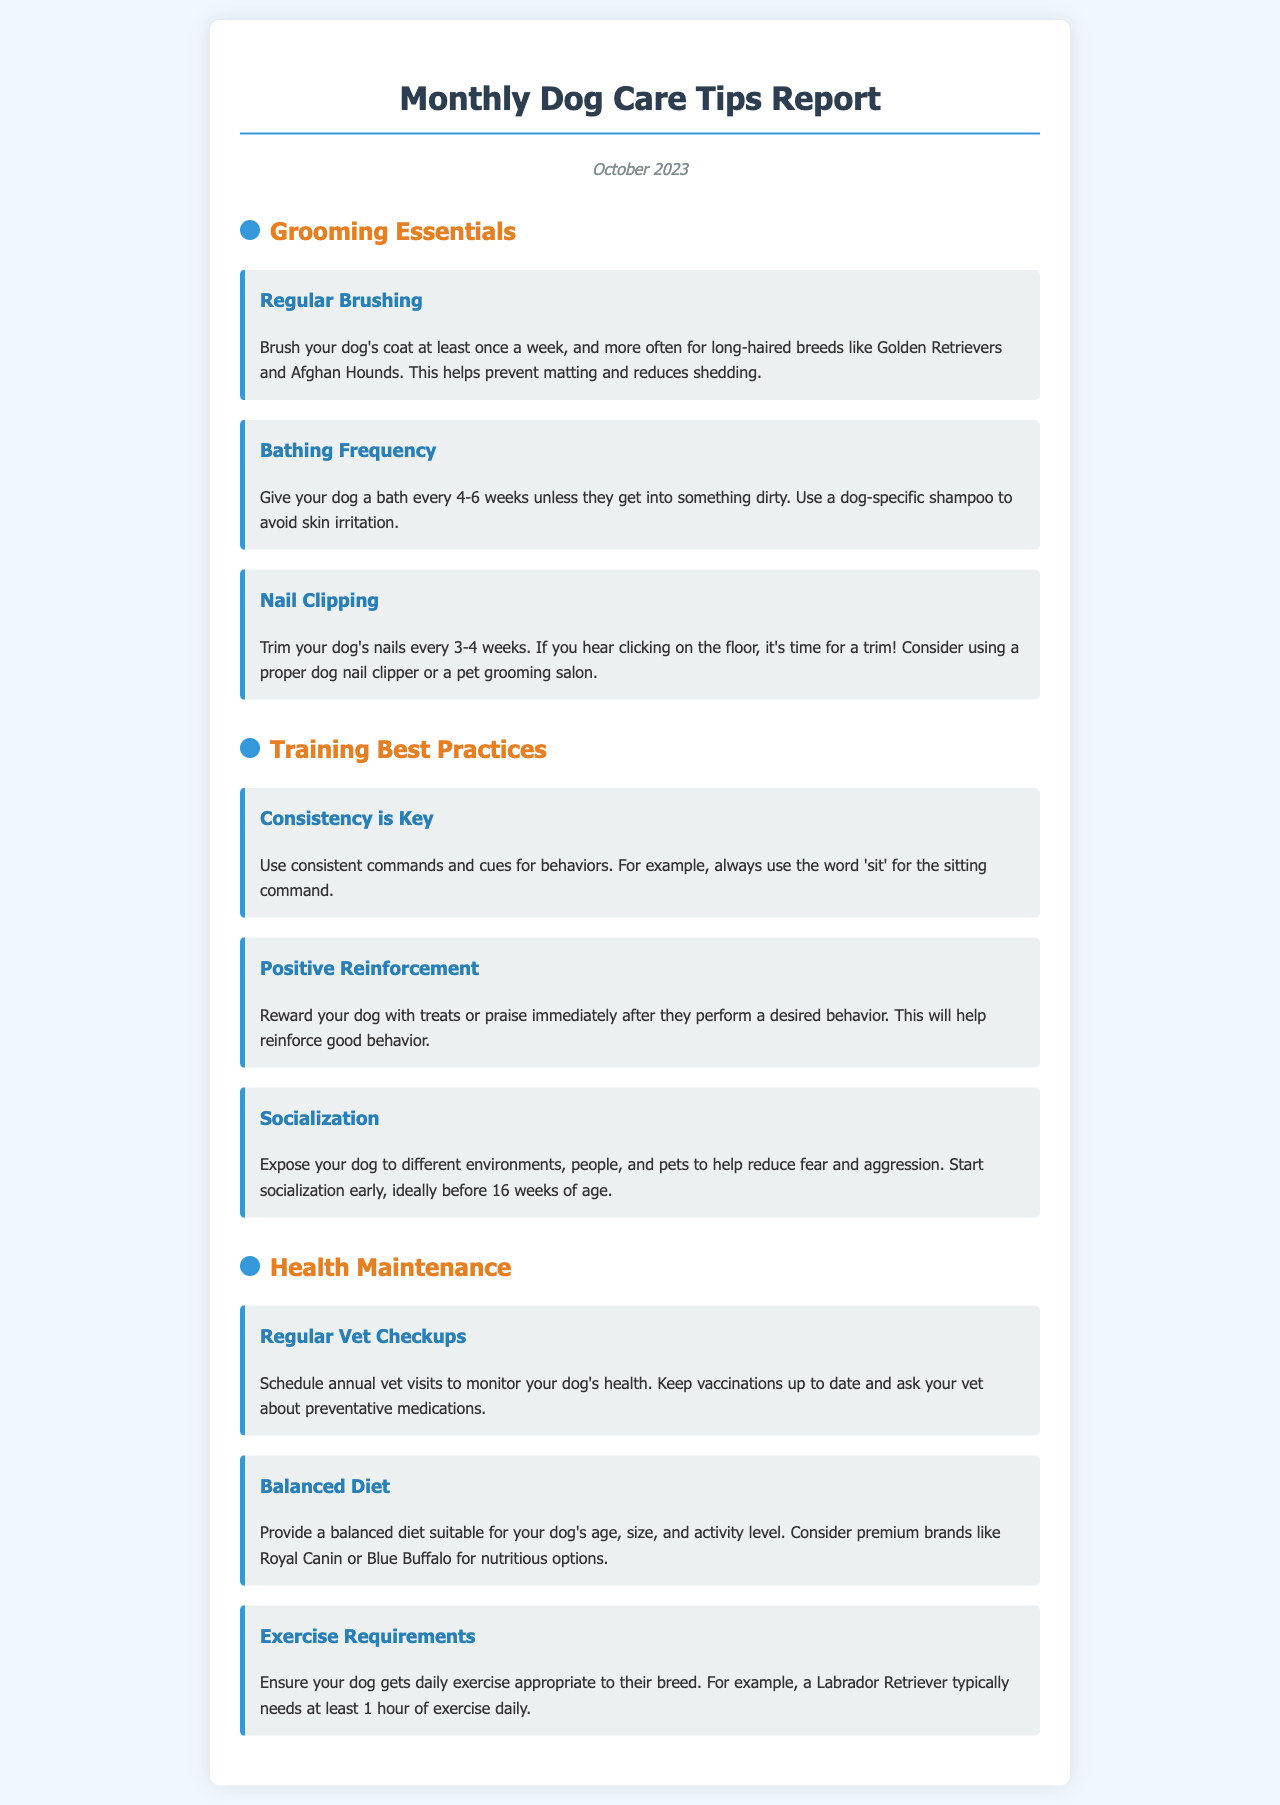What is the frequency for regular brushing? The document states that regular brushing should be done at least once a week.
Answer: Once a week How often should you give your dog a bath? The bathing frequency recommended is every 4-6 weeks unless they get dirty.
Answer: Every 4-6 weeks What is essential to ensure while training a dog? The best practice for dog training highlighted is consistency in commands and cues.
Answer: Consistency What should be included in your dog's diet? The document advises providing a balanced diet suitable for your dog's age, size, and activity level.
Answer: Balanced diet How often should nails be trimmed? The recommended frequency for trimming a dog's nails is every 3-4 weeks.
Answer: Every 3-4 weeks What should you do to help reduce fear and aggression in dogs? The document suggests socializing your dog by exposing them to different environments, people, and pets.
Answer: Socialization What type of shampoo should be used for dogs? Dog-specific shampoo is recommended to avoid skin irritation.
Answer: Dog-specific shampoo How long should a Labrador Retriever's daily exercise be? The document states that a Labrador Retriever typically needs at least 1 hour of exercise daily.
Answer: At least 1 hour When should you schedule your dog's vet checkups? Annual vet visits are recommended to monitor your dog's health.
Answer: Annual 